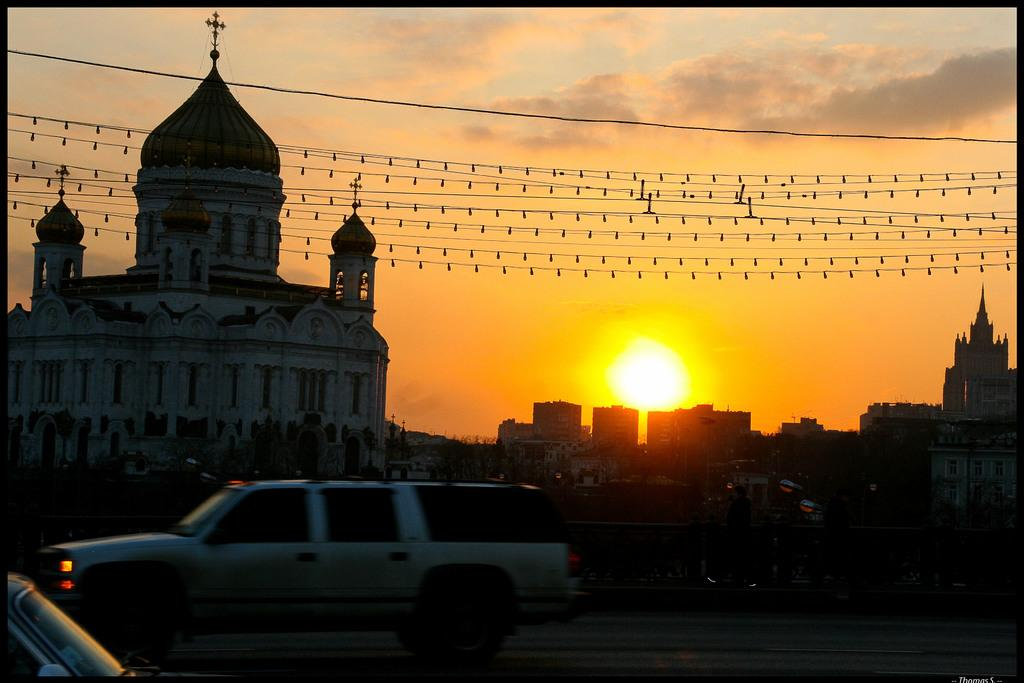What type of structures can be seen in the image? There is a group of buildings in the image. What is the purpose of the barrier in the image? There is a fence in the image, which serves as a barrier or boundary. What type of transportation is visible on the road in the image? There are vehicles on the road in the image. What celestial body is visible in the image? The sun is visible in the image. What is attached to the wires in the image? There are lights attached to the wires in the image. What is the condition of the sky in the image? The sky appears cloudy in the image. Where are the flowers growing in the image? There are no flowers present in the image. What type of rod is being used to measure the depth of the buildings in the image? There is no rod being used to measure the depth of the buildings in the image. 